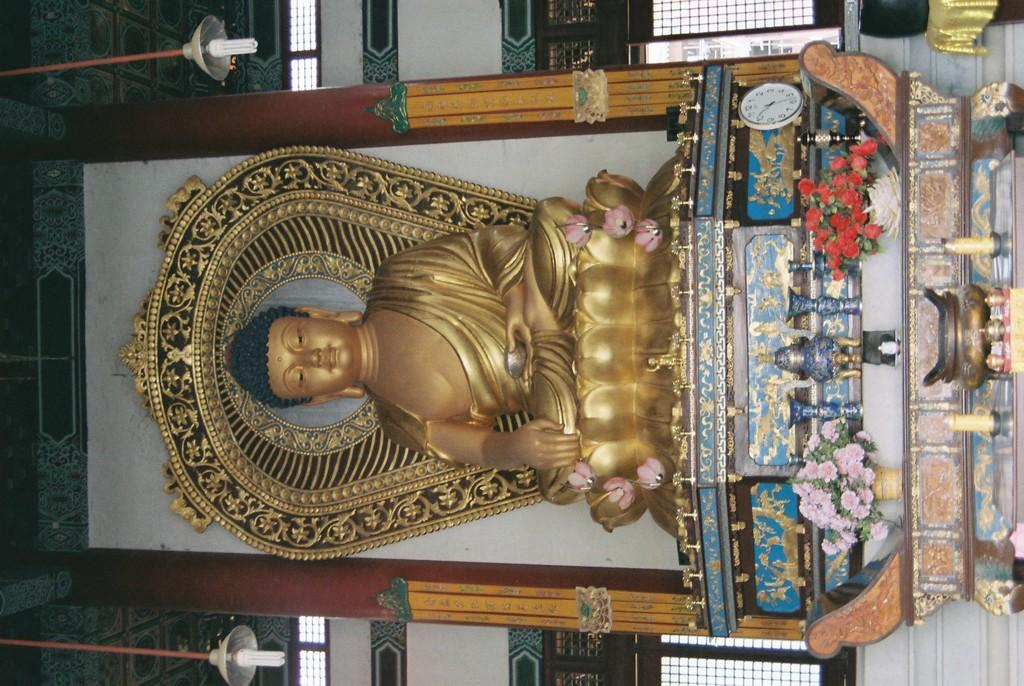What is the main subject of the image? There is a statue of Buddha in the image. What can be seen under the statue? There are flower vases and other objects under the statue. What is visible around the statue? There are windows around the statue. How many expert bakers are present in the image? There are no expert bakers present in the image; it features a statue of Buddha with flower vases and other objects under it, and windows around it. What type of force is being applied to the statue in the image? There is no force being applied to the statue in the image; it is stationary and not moving. 